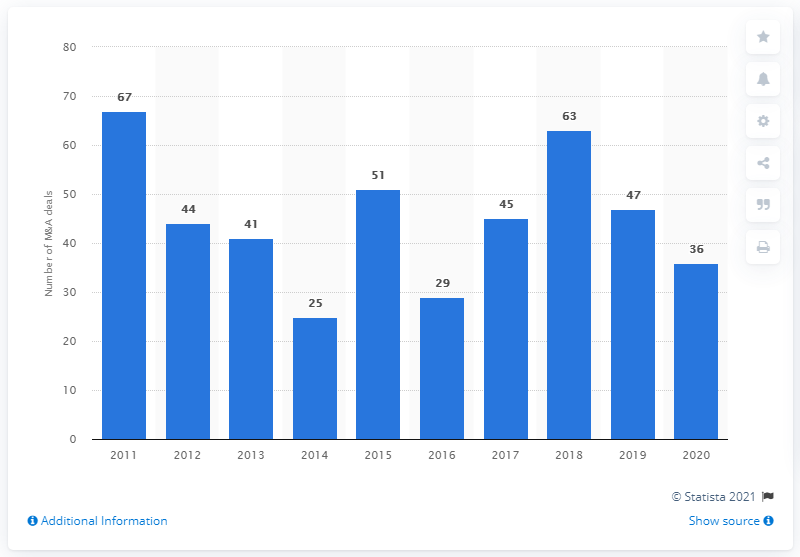Give some essential details in this illustration. In the period between 2011 and 2020, a total of 36 M&A deals were completed. 